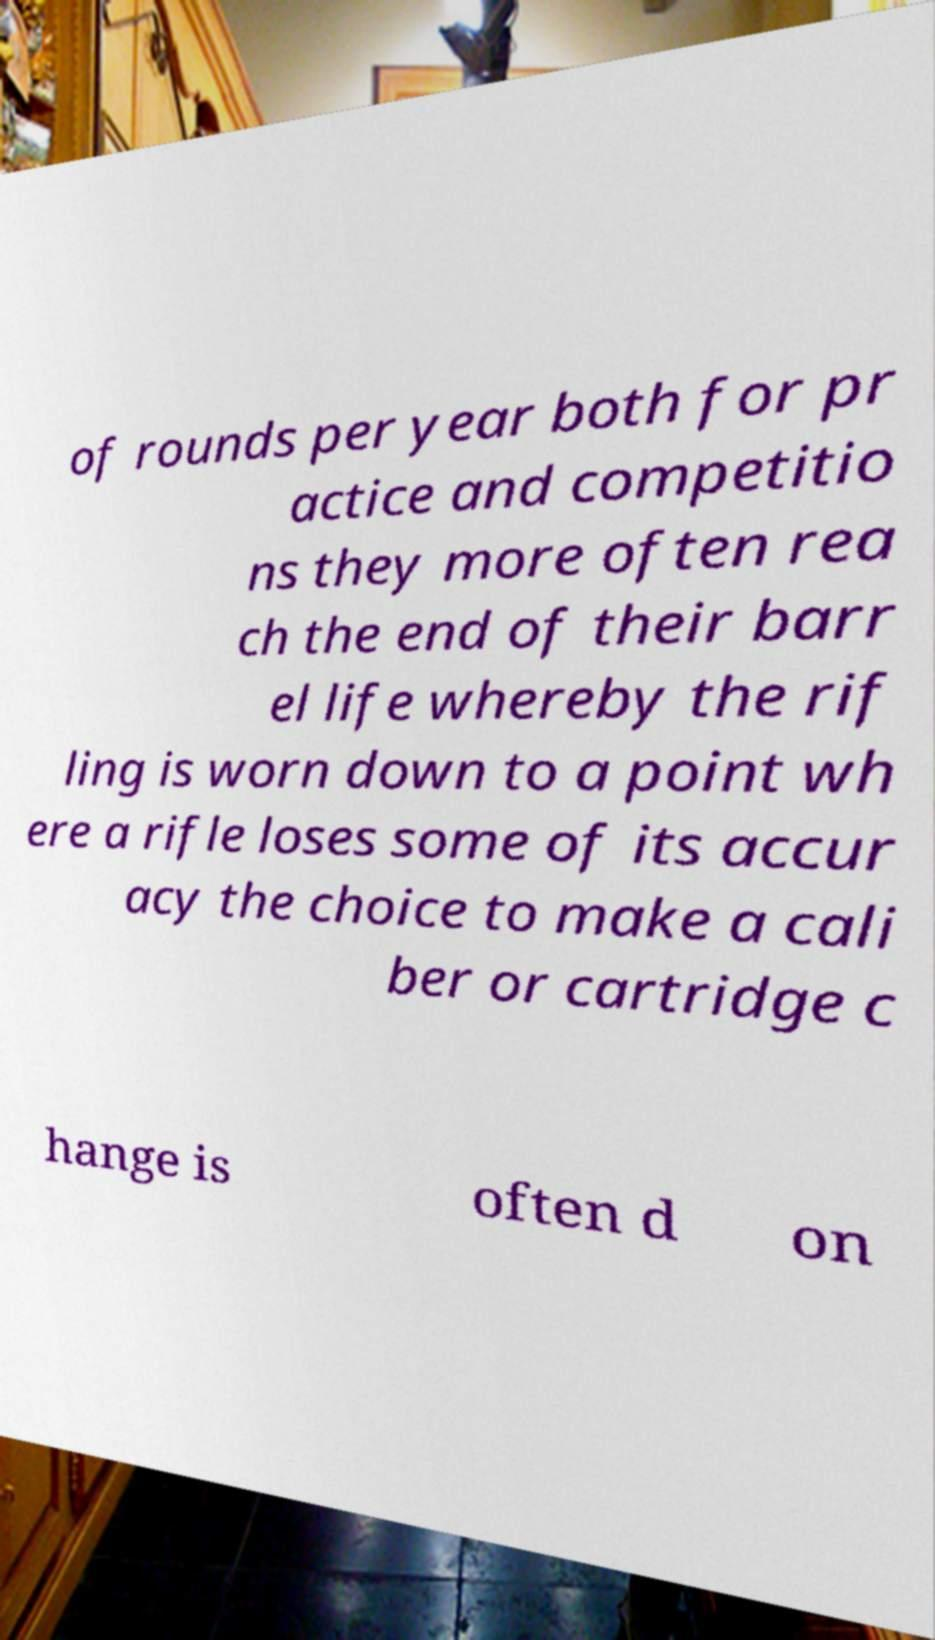What messages or text are displayed in this image? I need them in a readable, typed format. of rounds per year both for pr actice and competitio ns they more often rea ch the end of their barr el life whereby the rif ling is worn down to a point wh ere a rifle loses some of its accur acy the choice to make a cali ber or cartridge c hange is often d on 